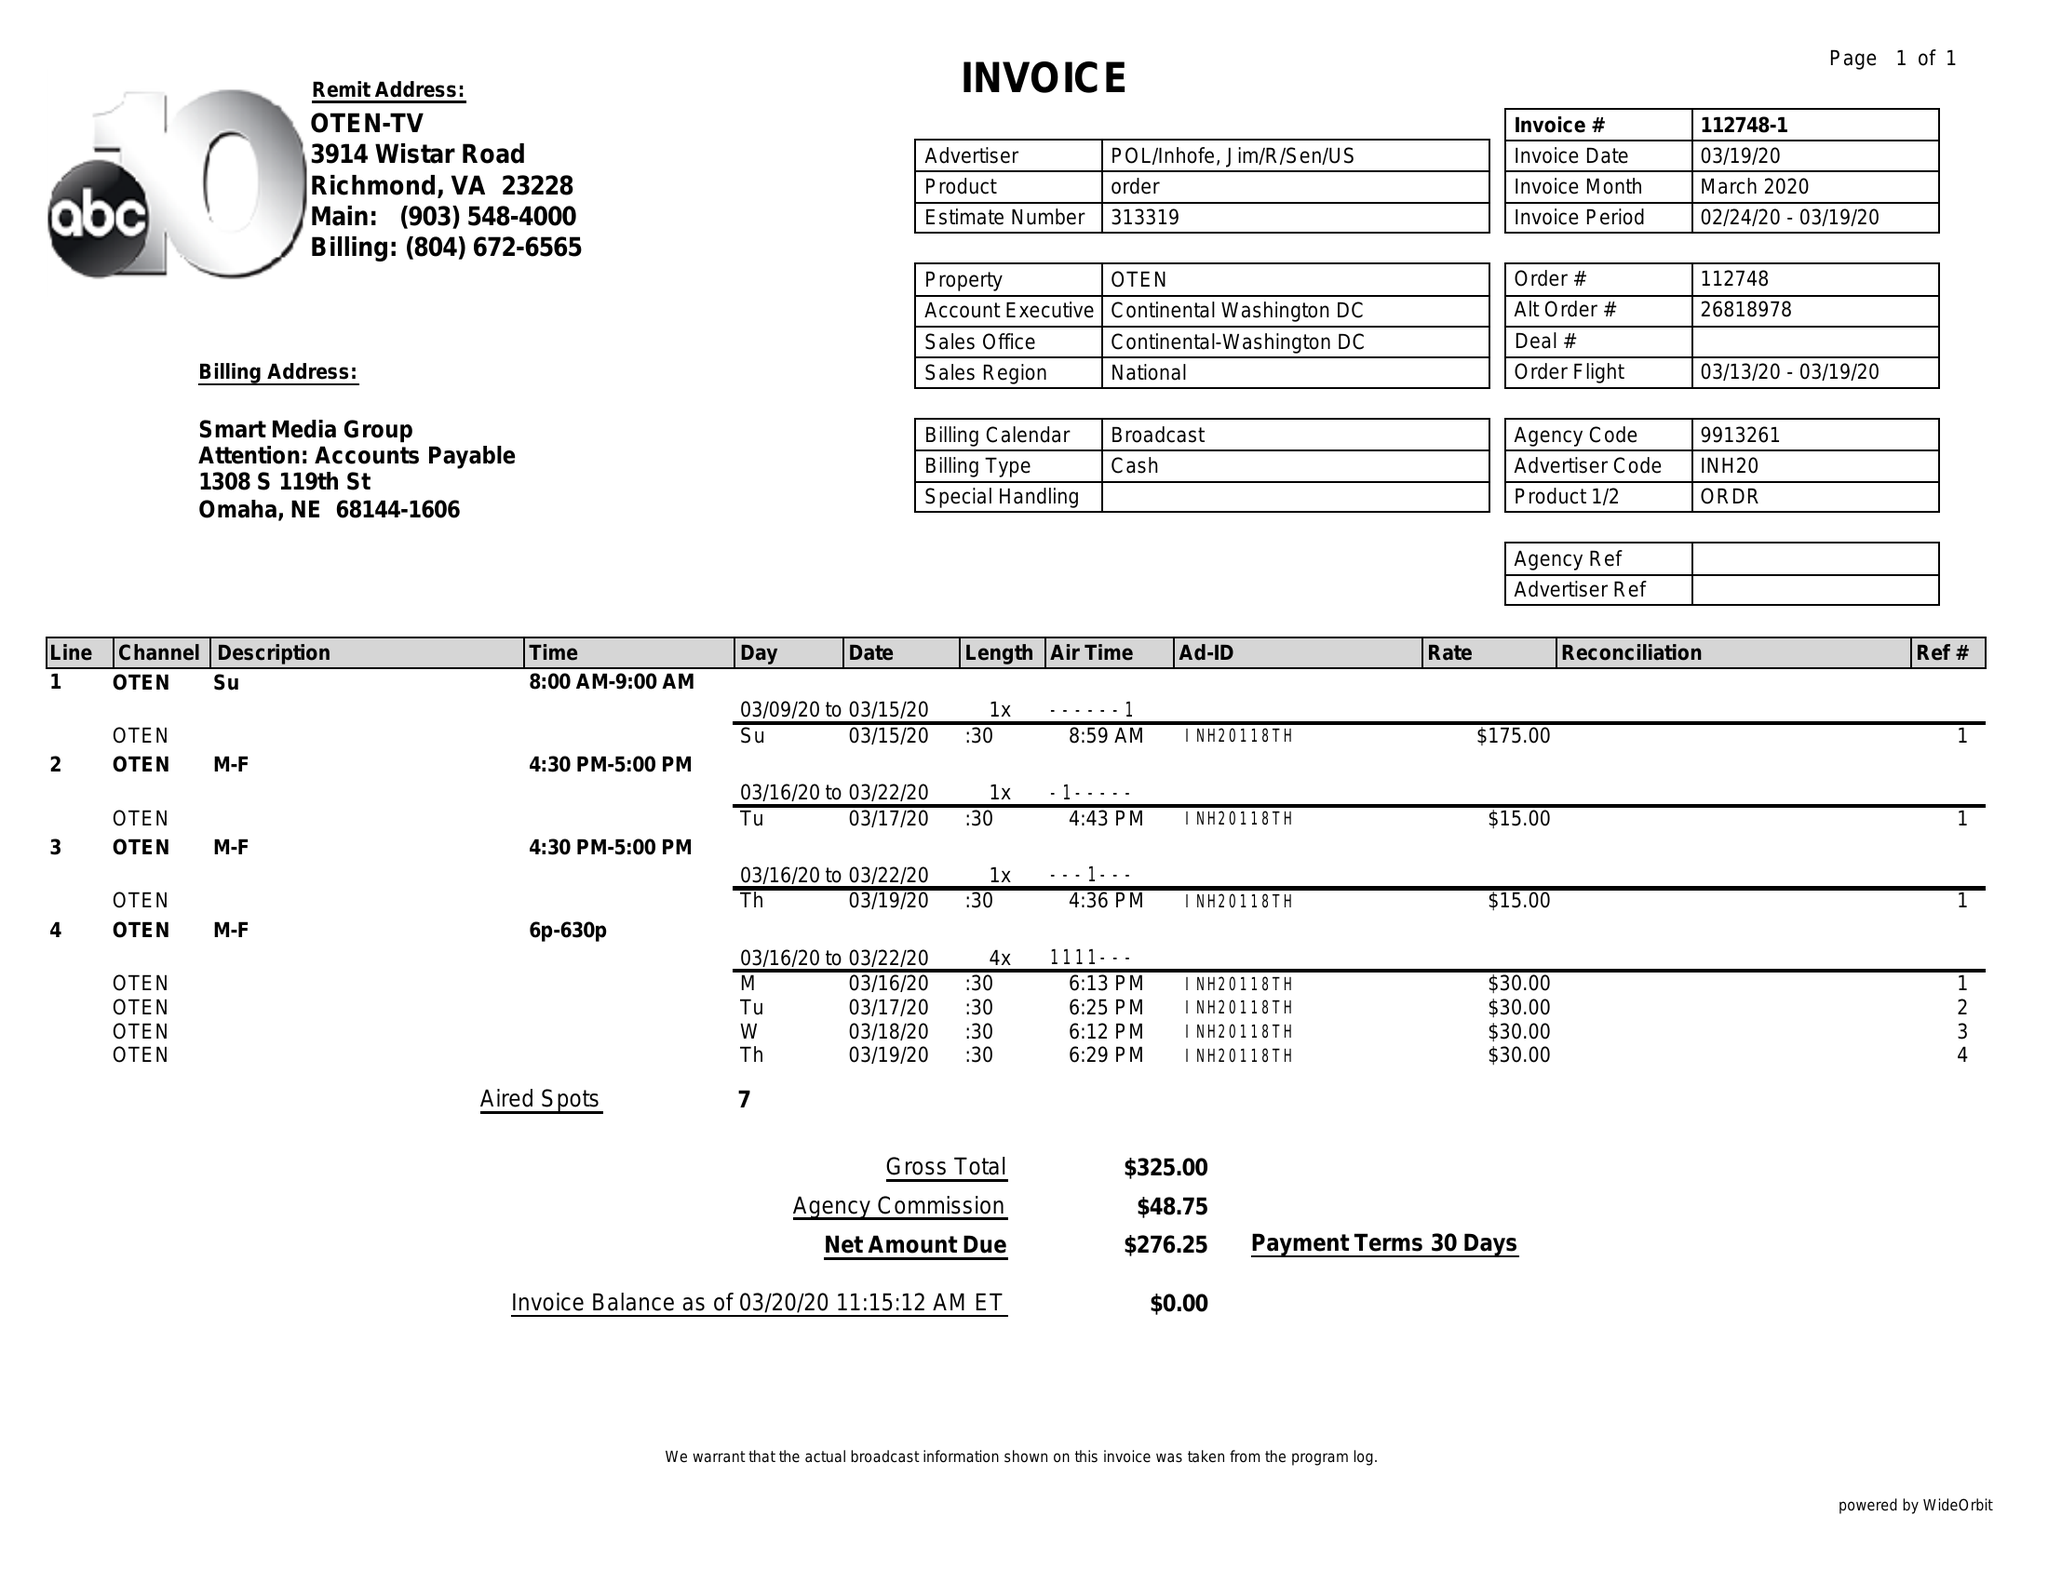What is the value for the gross_amount?
Answer the question using a single word or phrase. 325.00 